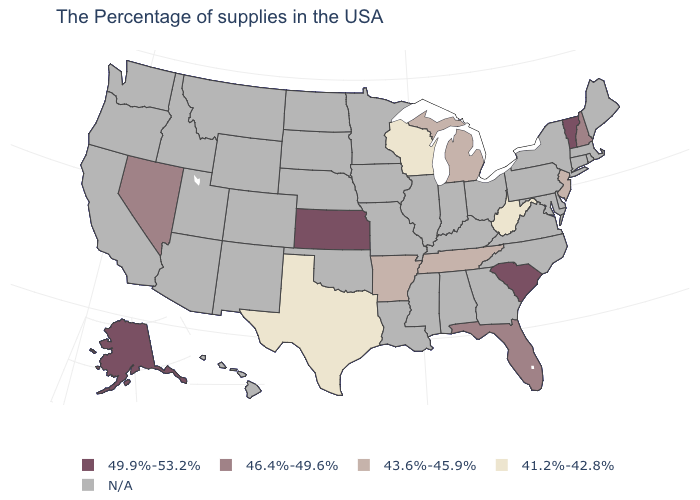What is the value of Massachusetts?
Short answer required. N/A. Does the first symbol in the legend represent the smallest category?
Give a very brief answer. No. Among the states that border New Hampshire , which have the highest value?
Quick response, please. Vermont. Does South Carolina have the highest value in the USA?
Concise answer only. Yes. What is the value of Arkansas?
Quick response, please. 43.6%-45.9%. Name the states that have a value in the range 43.6%-45.9%?
Answer briefly. New Jersey, Michigan, Tennessee, Arkansas. What is the lowest value in the West?
Keep it brief. 46.4%-49.6%. Does South Carolina have the lowest value in the USA?
Give a very brief answer. No. What is the value of New Jersey?
Quick response, please. 43.6%-45.9%. What is the value of North Dakota?
Write a very short answer. N/A. What is the highest value in the Northeast ?
Keep it brief. 49.9%-53.2%. Which states hav the highest value in the West?
Concise answer only. Alaska. What is the highest value in states that border Idaho?
Give a very brief answer. 46.4%-49.6%. What is the highest value in the USA?
Keep it brief. 49.9%-53.2%. 